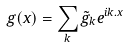<formula> <loc_0><loc_0><loc_500><loc_500>g ( { x } ) = \sum _ { k } { \tilde { g } } _ { k } e ^ { i { k . x } }</formula> 